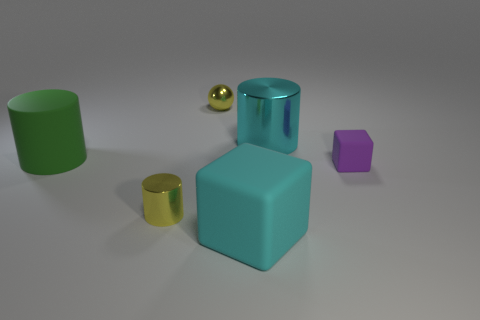Add 3 tiny yellow cylinders. How many objects exist? 9 Subtract all cubes. How many objects are left? 4 Add 5 tiny metal spheres. How many tiny metal spheres are left? 6 Add 6 small cyan shiny cylinders. How many small cyan shiny cylinders exist? 6 Subtract 0 brown cubes. How many objects are left? 6 Subtract all large cyan rubber things. Subtract all big yellow metal blocks. How many objects are left? 5 